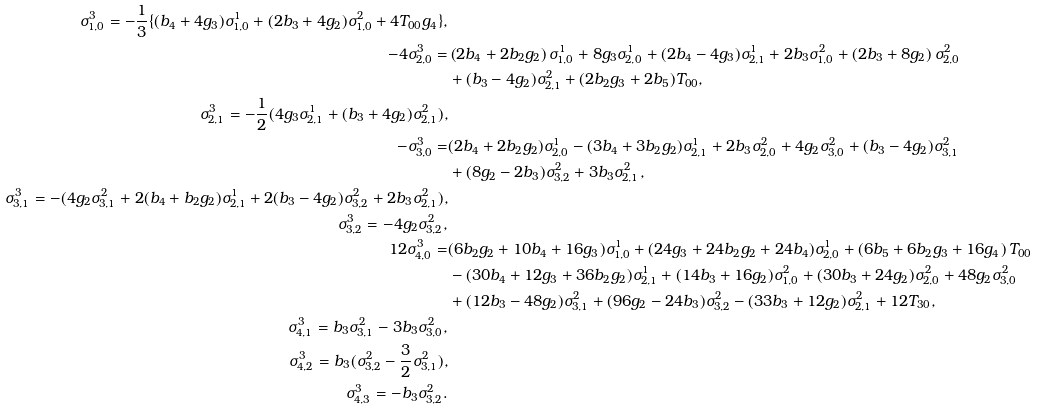Convert formula to latex. <formula><loc_0><loc_0><loc_500><loc_500>\sigma _ { 1 , 0 } ^ { 3 } = - \frac { 1 } { 3 } \{ ( b _ { 4 } + 4 g _ { 3 } ) \sigma _ { 1 , 0 } ^ { 1 } + ( 2 b _ { 3 } + 4 g _ { 2 } ) \sigma _ { 1 , 0 } ^ { 2 } + 4 T _ { 0 0 } g _ { 4 } \} , \\ - 4 \sigma _ { 2 , 0 } ^ { 3 } = & \left ( 2 b _ { 4 } + 2 b _ { 2 } g _ { 2 } \right ) \sigma _ { 1 , 0 } ^ { 1 } + 8 g _ { 3 } \sigma _ { 2 , 0 } ^ { 1 } + ( 2 b _ { 4 } - 4 g _ { 3 } ) \sigma _ { 2 , 1 } ^ { 1 } + 2 b _ { 3 } \sigma _ { 1 , 0 } ^ { 2 } + \left ( 2 b _ { 3 } + 8 g _ { 2 } \right ) \sigma _ { 2 , 0 } ^ { 2 } \\ & + ( b _ { 3 } - 4 g _ { 2 } ) \sigma _ { 2 , 1 } ^ { 2 } + ( 2 b _ { 2 } g _ { 3 } + 2 b _ { 5 } ) T _ { 0 0 } , \\ \sigma _ { 2 , 1 } ^ { 3 } = - \frac { 1 } { 2 } ( 4 g _ { 3 } \sigma _ { 2 , 1 } ^ { 1 } + ( b _ { 3 } + 4 g _ { 2 } ) \sigma _ { 2 , 1 } ^ { 2 } ) , \\ - \sigma _ { 3 , 0 } ^ { 3 } = & ( 2 b _ { 4 } + 2 b _ { 2 } g _ { 2 } ) \sigma _ { 2 , 0 } ^ { 1 } - ( 3 b _ { 4 } + 3 b _ { 2 } g _ { 2 } ) \sigma _ { 2 , 1 } ^ { 1 } + 2 b _ { 3 } \sigma _ { 2 , 0 } ^ { 2 } + 4 g _ { 2 } \sigma _ { 3 , 0 } ^ { 2 } + ( b _ { 3 } - 4 g _ { 2 } ) \sigma _ { 3 , 1 } ^ { 2 } \\ & + ( 8 g _ { 2 } - 2 b _ { 3 } ) \sigma _ { 3 , 2 } ^ { 2 } + 3 b _ { 3 } \sigma _ { 2 , 1 } ^ { 2 } , \\ \sigma _ { 3 , 1 } ^ { 3 } = - ( 4 g _ { 2 } \sigma _ { 3 , 1 } ^ { 2 } + 2 ( b _ { 4 } + b _ { 2 } g _ { 2 } ) \sigma _ { 2 , 1 } ^ { 1 } + 2 ( b _ { 3 } - 4 g _ { 2 } ) \sigma _ { 3 , 2 } ^ { 2 } + 2 b _ { 3 } \sigma _ { 2 , 1 } ^ { 2 } ) , \\ \sigma _ { 3 , 2 } ^ { 3 } = - 4 g _ { 2 } \sigma _ { 3 , 2 } ^ { 2 } , \\ 1 2 \sigma _ { 4 , 0 } ^ { 3 } = & ( 6 b _ { 2 } g _ { 2 } + 1 0 b _ { 4 } + 1 6 g _ { 3 } ) \sigma _ { 1 , 0 } ^ { 1 } + ( 2 4 g _ { 3 } + 2 4 b _ { 2 } g _ { 2 } + 2 4 b _ { 4 } ) \sigma _ { 2 , 0 } ^ { 1 } + \left ( 6 b _ { 5 } + 6 b _ { 2 } g _ { 3 } + 1 6 g _ { 4 } \right ) T _ { 0 0 } \\ & - ( 3 0 b _ { 4 } + 1 2 g _ { 3 } + 3 6 b _ { 2 } g _ { 2 } ) \sigma _ { 2 , 1 } ^ { 1 } + ( 1 4 b _ { 3 } + 1 6 g _ { 2 } ) \sigma _ { 1 , 0 } ^ { 2 } + ( 3 0 b _ { 3 } + 2 4 g _ { 2 } ) \sigma _ { 2 , 0 } ^ { 2 } + 4 8 g _ { 2 } \sigma _ { 3 , 0 } ^ { 2 } \\ & + ( 1 2 b _ { 3 } - 4 8 g _ { 2 } ) \sigma _ { 3 , 1 } ^ { 2 } + ( 9 6 g _ { 2 } - 2 4 b _ { 3 } ) \sigma _ { 3 , 2 } ^ { 2 } - ( 3 3 b _ { 3 } + 1 2 g _ { 2 } ) \sigma _ { 2 , 1 } ^ { 2 } + 1 2 T _ { 3 0 } , \\ \sigma _ { 4 , 1 } ^ { 3 } = b _ { 3 } \sigma _ { 3 , 1 } ^ { 2 } - 3 b _ { 3 } \sigma _ { 3 , 0 } ^ { 2 } , \\ \sigma _ { 4 , 2 } ^ { 3 } = b _ { 3 } ( \sigma _ { 3 , 2 } ^ { 2 } - \frac { 3 } { 2 } \sigma _ { 3 , 1 } ^ { 2 } ) , \\ \sigma _ { 4 , 3 } ^ { 3 } = - b _ { 3 } \sigma _ { 3 , 2 } ^ { 2 } .</formula> 